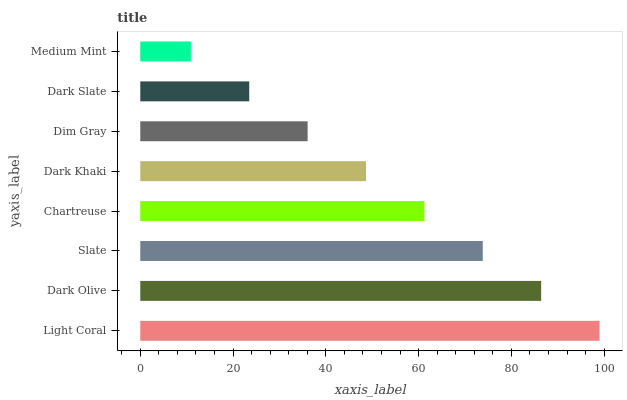Is Medium Mint the minimum?
Answer yes or no. Yes. Is Light Coral the maximum?
Answer yes or no. Yes. Is Dark Olive the minimum?
Answer yes or no. No. Is Dark Olive the maximum?
Answer yes or no. No. Is Light Coral greater than Dark Olive?
Answer yes or no. Yes. Is Dark Olive less than Light Coral?
Answer yes or no. Yes. Is Dark Olive greater than Light Coral?
Answer yes or no. No. Is Light Coral less than Dark Olive?
Answer yes or no. No. Is Chartreuse the high median?
Answer yes or no. Yes. Is Dark Khaki the low median?
Answer yes or no. Yes. Is Dim Gray the high median?
Answer yes or no. No. Is Slate the low median?
Answer yes or no. No. 